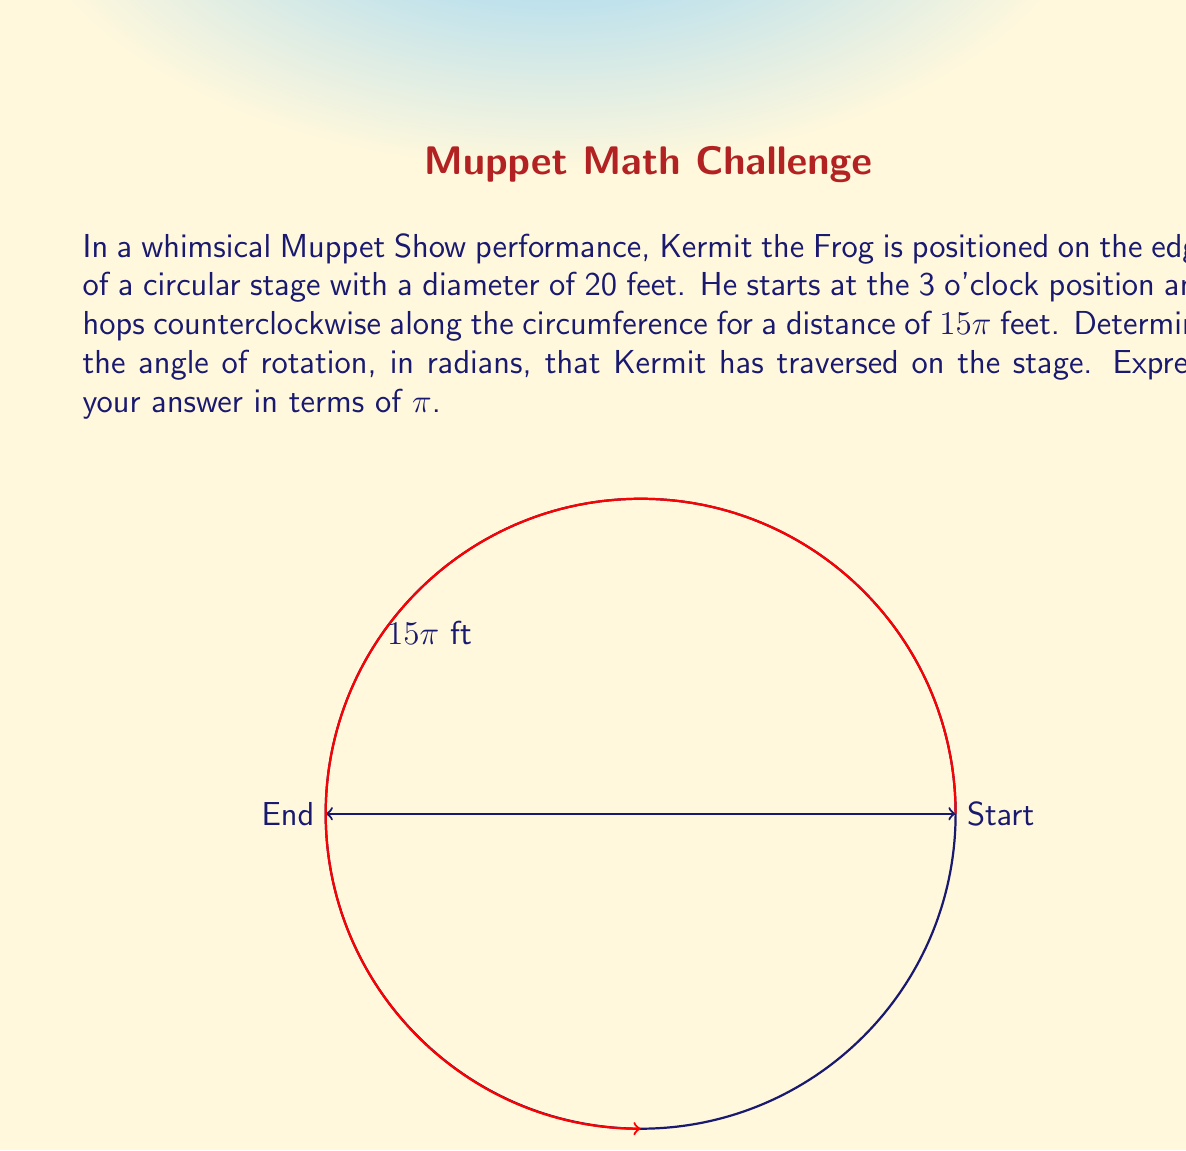Teach me how to tackle this problem. Let's approach this step-by-step:

1) First, we need to recall the formula for the circumference of a circle:
   
   $C = 2\pi r$, where $r$ is the radius

2) We're given the diameter of 20 feet, so the radius is 10 feet.

3) Now, let's consider the relationship between the angle of rotation ($\theta$) in radians, the radius ($r$), and the arc length ($s$):
   
   $\theta = \frac{s}{r}$

4) We're told that Kermit hops a distance of $15\pi$ feet along the circumference. This is our arc length $s$.

5) Substituting these values into our formula:

   $\theta = \frac{15\pi}{10} = \frac{3\pi}{2}$

6) To verify, we can check if this makes sense:
   - A full rotation is $2\pi$ radians
   - $\frac{3\pi}{2}$ is exactly $\frac{3}{4}$ of a full rotation
   - This corresponds to 270°, which matches the diagram (from 3 o'clock to 12 o'clock position)

Therefore, Kermit has rotated $\frac{3\pi}{2}$ radians on the stage.
Answer: $\frac{3\pi}{2}$ radians 